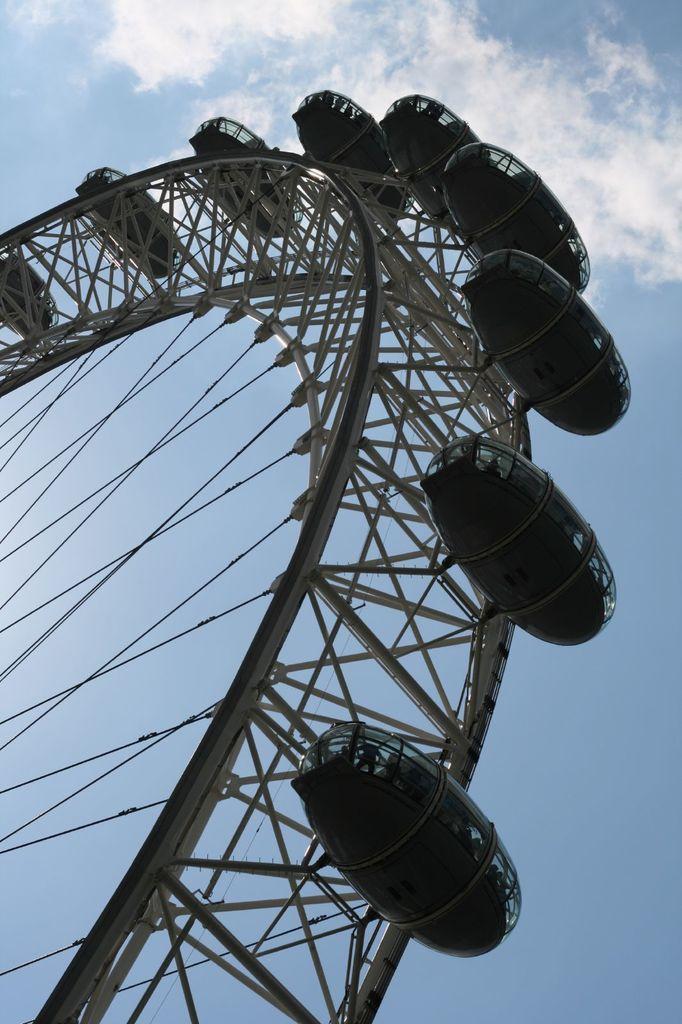Describe this image in one or two sentences. In this image we can see a Ferris wheel. In the background, we can see the cloudy sky. 